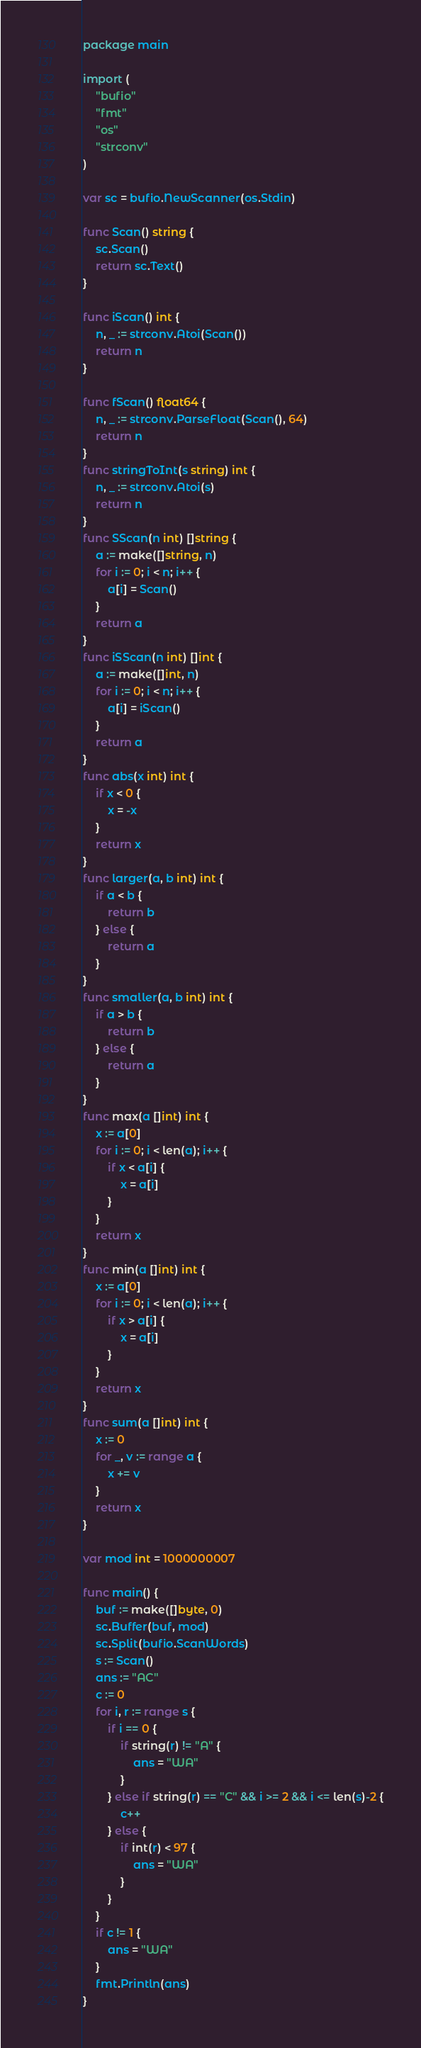<code> <loc_0><loc_0><loc_500><loc_500><_Go_>package main

import (
	"bufio"
	"fmt"
	"os"
	"strconv"
)

var sc = bufio.NewScanner(os.Stdin)

func Scan() string {
	sc.Scan()
	return sc.Text()
}

func iScan() int {
	n, _ := strconv.Atoi(Scan())
	return n
}

func fScan() float64 {
	n, _ := strconv.ParseFloat(Scan(), 64)
	return n
}
func stringToInt(s string) int {
	n, _ := strconv.Atoi(s)
	return n
}
func SScan(n int) []string {
	a := make([]string, n)
	for i := 0; i < n; i++ {
		a[i] = Scan()
	}
	return a
}
func iSScan(n int) []int {
	a := make([]int, n)
	for i := 0; i < n; i++ {
		a[i] = iScan()
	}
	return a
}
func abs(x int) int {
	if x < 0 {
		x = -x
	}
	return x
}
func larger(a, b int) int {
	if a < b {
		return b
	} else {
		return a
	}
}
func smaller(a, b int) int {
	if a > b {
		return b
	} else {
		return a
	}
}
func max(a []int) int {
	x := a[0]
	for i := 0; i < len(a); i++ {
		if x < a[i] {
			x = a[i]
		}
	}
	return x
}
func min(a []int) int {
	x := a[0]
	for i := 0; i < len(a); i++ {
		if x > a[i] {
			x = a[i]
		}
	}
	return x
}
func sum(a []int) int {
	x := 0
	for _, v := range a {
		x += v
	}
	return x
}

var mod int = 1000000007

func main() {
	buf := make([]byte, 0)
	sc.Buffer(buf, mod)
	sc.Split(bufio.ScanWords)
	s := Scan()
	ans := "AC"
	c := 0
	for i, r := range s {
		if i == 0 {
			if string(r) != "A" {
				ans = "WA"
			}
		} else if string(r) == "C" && i >= 2 && i <= len(s)-2 {
			c++
		} else {
			if int(r) < 97 {
				ans = "WA"
			}
		}
	}
	if c != 1 {
		ans = "WA"
	}
	fmt.Println(ans)
}
</code> 